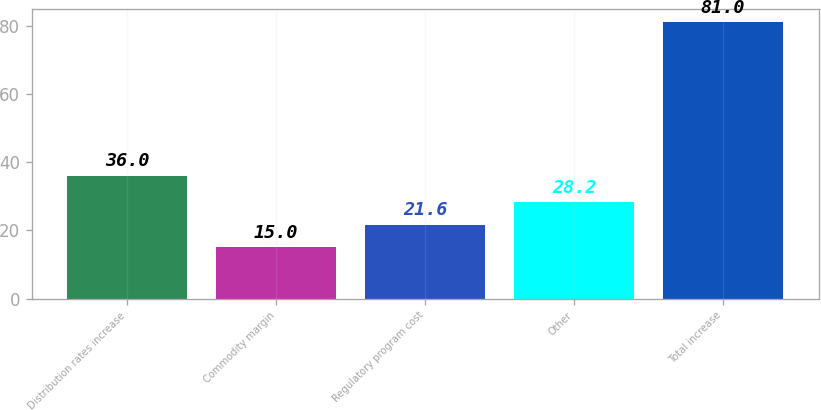Convert chart. <chart><loc_0><loc_0><loc_500><loc_500><bar_chart><fcel>Distribution rates increase<fcel>Commodity margin<fcel>Regulatory program cost<fcel>Other<fcel>Total increase<nl><fcel>36<fcel>15<fcel>21.6<fcel>28.2<fcel>81<nl></chart> 